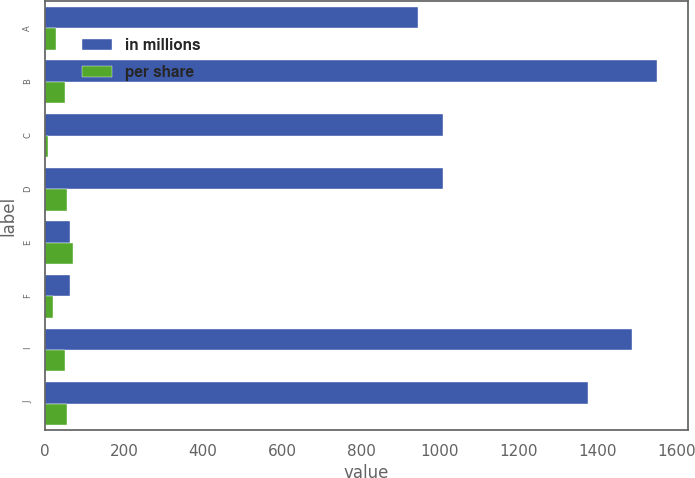Convert chart to OTSL. <chart><loc_0><loc_0><loc_500><loc_500><stacked_bar_chart><ecel><fcel>A<fcel>B<fcel>C<fcel>D<fcel>E<fcel>F<fcel>I<fcel>J<nl><fcel>in millions<fcel>945.32<fcel>1550<fcel>1008.34<fcel>1008.34<fcel>63<fcel>63<fcel>1487.52<fcel>1375<nl><fcel>per share<fcel>28<fcel>50<fcel>8<fcel>54<fcel>71<fcel>20<fcel>51<fcel>55<nl></chart> 